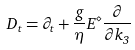<formula> <loc_0><loc_0><loc_500><loc_500>D _ { t } = \partial _ { t } + \frac { g } { \eta } E ^ { \diamond } \frac { \partial } { \partial k _ { 3 } }</formula> 